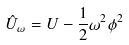Convert formula to latex. <formula><loc_0><loc_0><loc_500><loc_500>\hat { U } _ { \omega } = U - \frac { 1 } { 2 } \omega ^ { 2 } \phi ^ { 2 }</formula> 